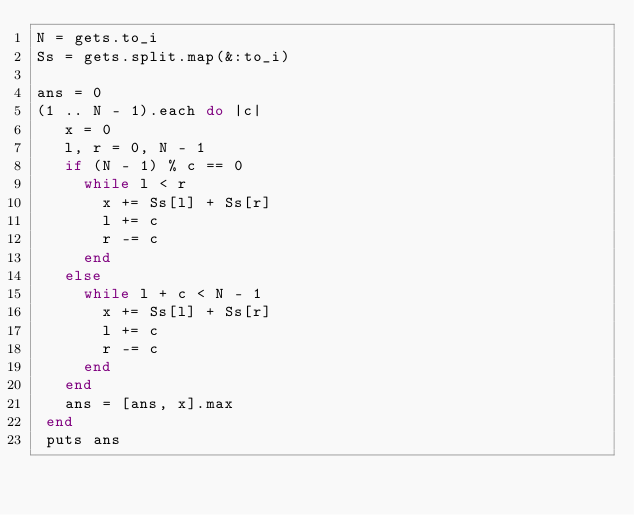<code> <loc_0><loc_0><loc_500><loc_500><_Ruby_>N = gets.to_i
Ss = gets.split.map(&:to_i)

ans = 0
(1 .. N - 1).each do |c|
   x = 0
   l, r = 0, N - 1
   if (N - 1) % c == 0
     while l < r
       x += Ss[l] + Ss[r]
       l += c
       r -= c
     end
   else
     while l + c < N - 1
       x += Ss[l] + Ss[r]
       l += c
       r -= c
     end
   end
   ans = [ans, x].max
 end
 puts ans</code> 